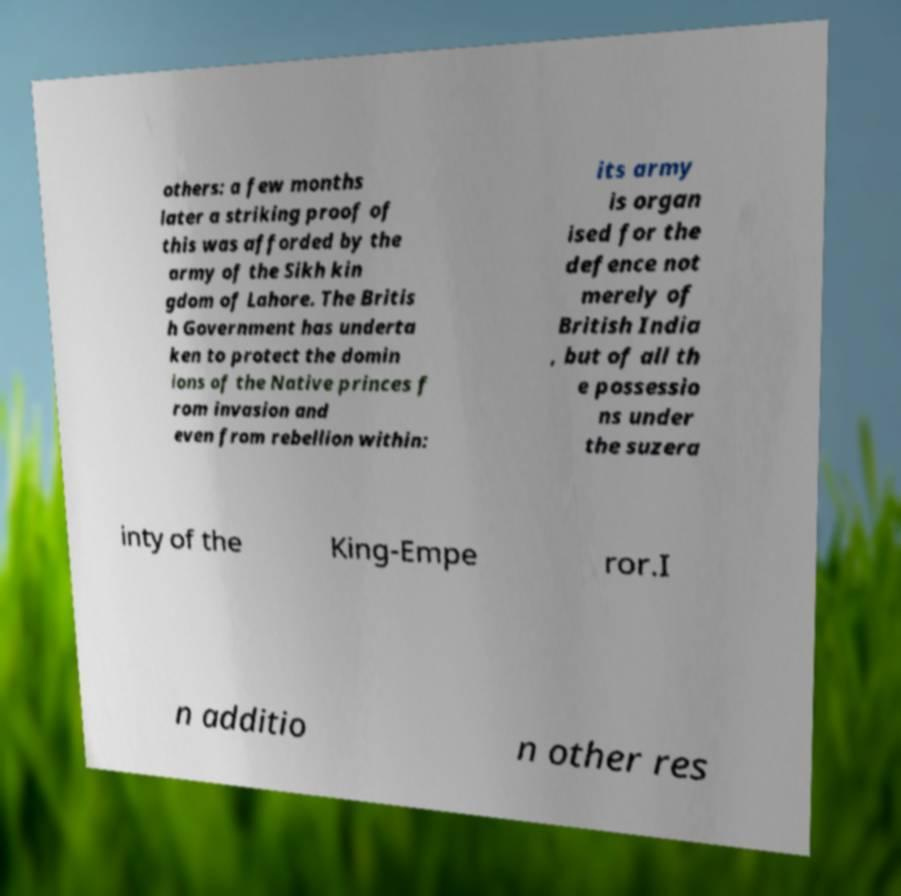Can you read and provide the text displayed in the image?This photo seems to have some interesting text. Can you extract and type it out for me? others: a few months later a striking proof of this was afforded by the army of the Sikh kin gdom of Lahore. The Britis h Government has underta ken to protect the domin ions of the Native princes f rom invasion and even from rebellion within: its army is organ ised for the defence not merely of British India , but of all th e possessio ns under the suzera inty of the King-Empe ror.I n additio n other res 